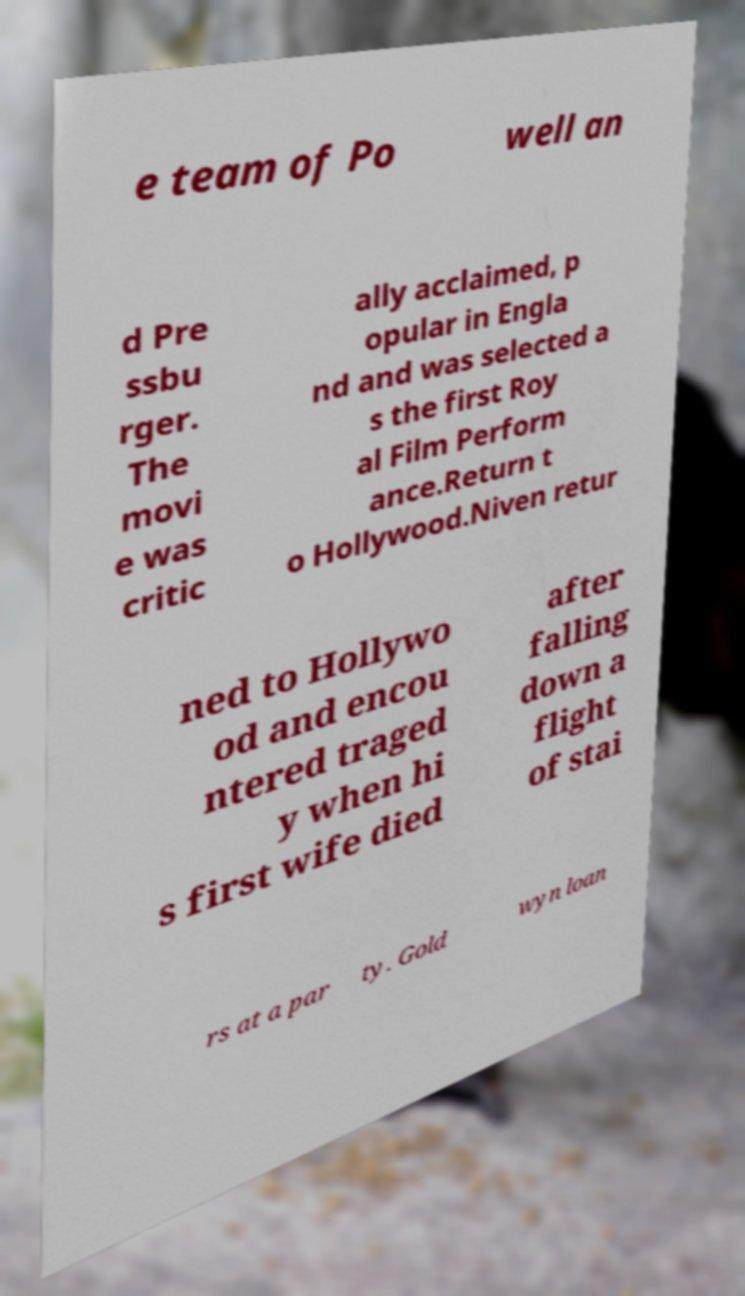I need the written content from this picture converted into text. Can you do that? e team of Po well an d Pre ssbu rger. The movi e was critic ally acclaimed, p opular in Engla nd and was selected a s the first Roy al Film Perform ance.Return t o Hollywood.Niven retur ned to Hollywo od and encou ntered traged y when hi s first wife died after falling down a flight of stai rs at a par ty. Gold wyn loan 